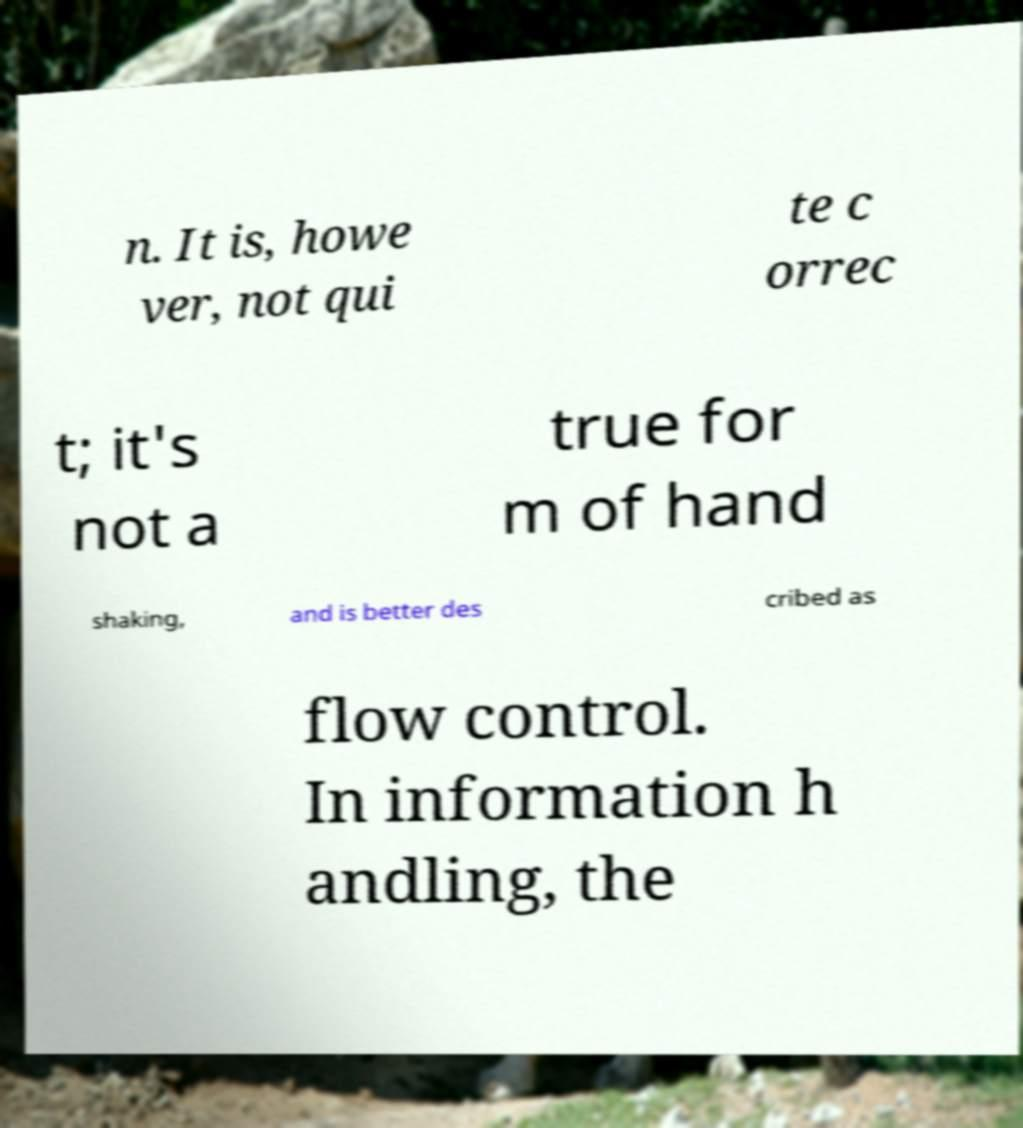Please identify and transcribe the text found in this image. n. It is, howe ver, not qui te c orrec t; it's not a true for m of hand shaking, and is better des cribed as flow control. In information h andling, the 